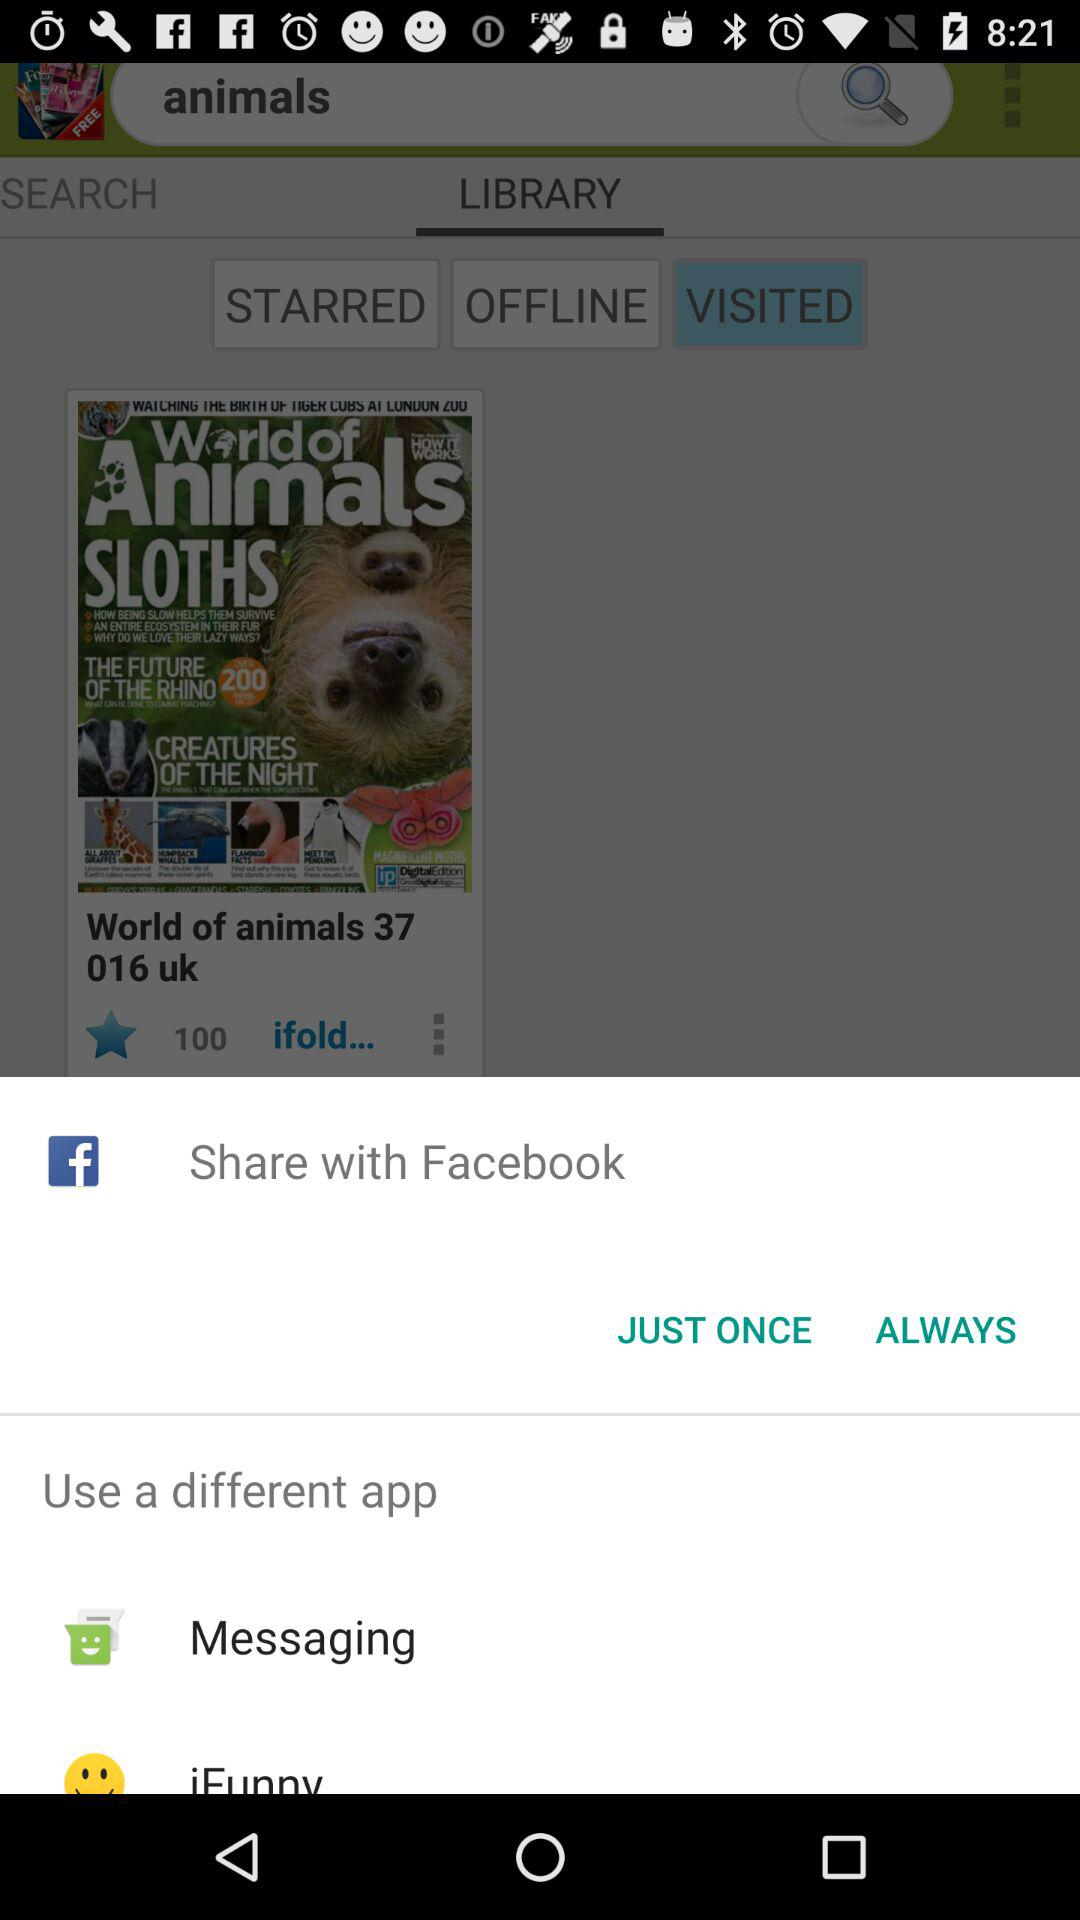What are the different apps I can use? The different apps you can use are "Facebook", "Messaging" and "iFunny". 